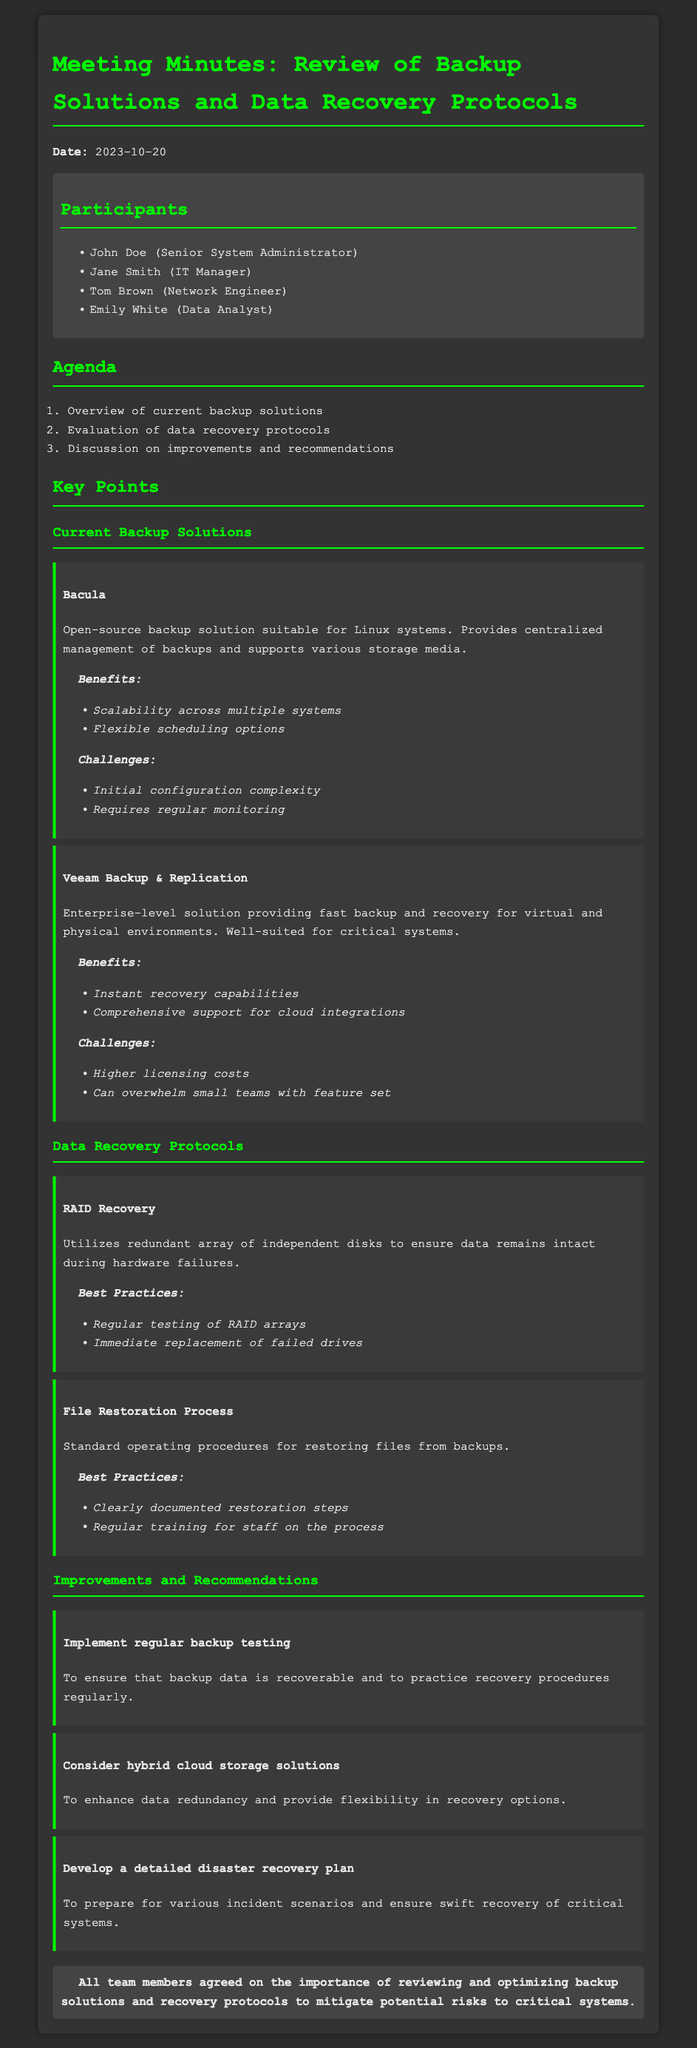What is the date of the meeting? The document states that the meeting took place on 2023-10-20.
Answer: 2023-10-20 Who is the Senior System Administrator? The participant list indicates that John Doe holds the position of Senior System Administrator.
Answer: John Doe What is the primary benefit of Bacula? The document lists scalability across multiple systems as a key benefit of Bacula.
Answer: Scalability across multiple systems What is a challenge of using Veeam Backup & Replication? The document identifies higher licensing costs as a challenge associated with Veeam Backup & Replication.
Answer: Higher licensing costs What is one of the best practices for RAID Recovery? The document suggests regular testing of RAID arrays as a best practice.
Answer: Regular testing of RAID arrays What is a recommendation made in the meeting? The meeting minutes mention implementing regular backup testing as a recommendation.
Answer: Implement regular backup testing How many participants were present at the meeting? The document lists four participants attending the meeting.
Answer: Four What does the conclusion emphasize? The conclusion underscores the agreement among team members on the importance of reviewing and optimizing backup solutions.
Answer: Importance of reviewing backup solutions 